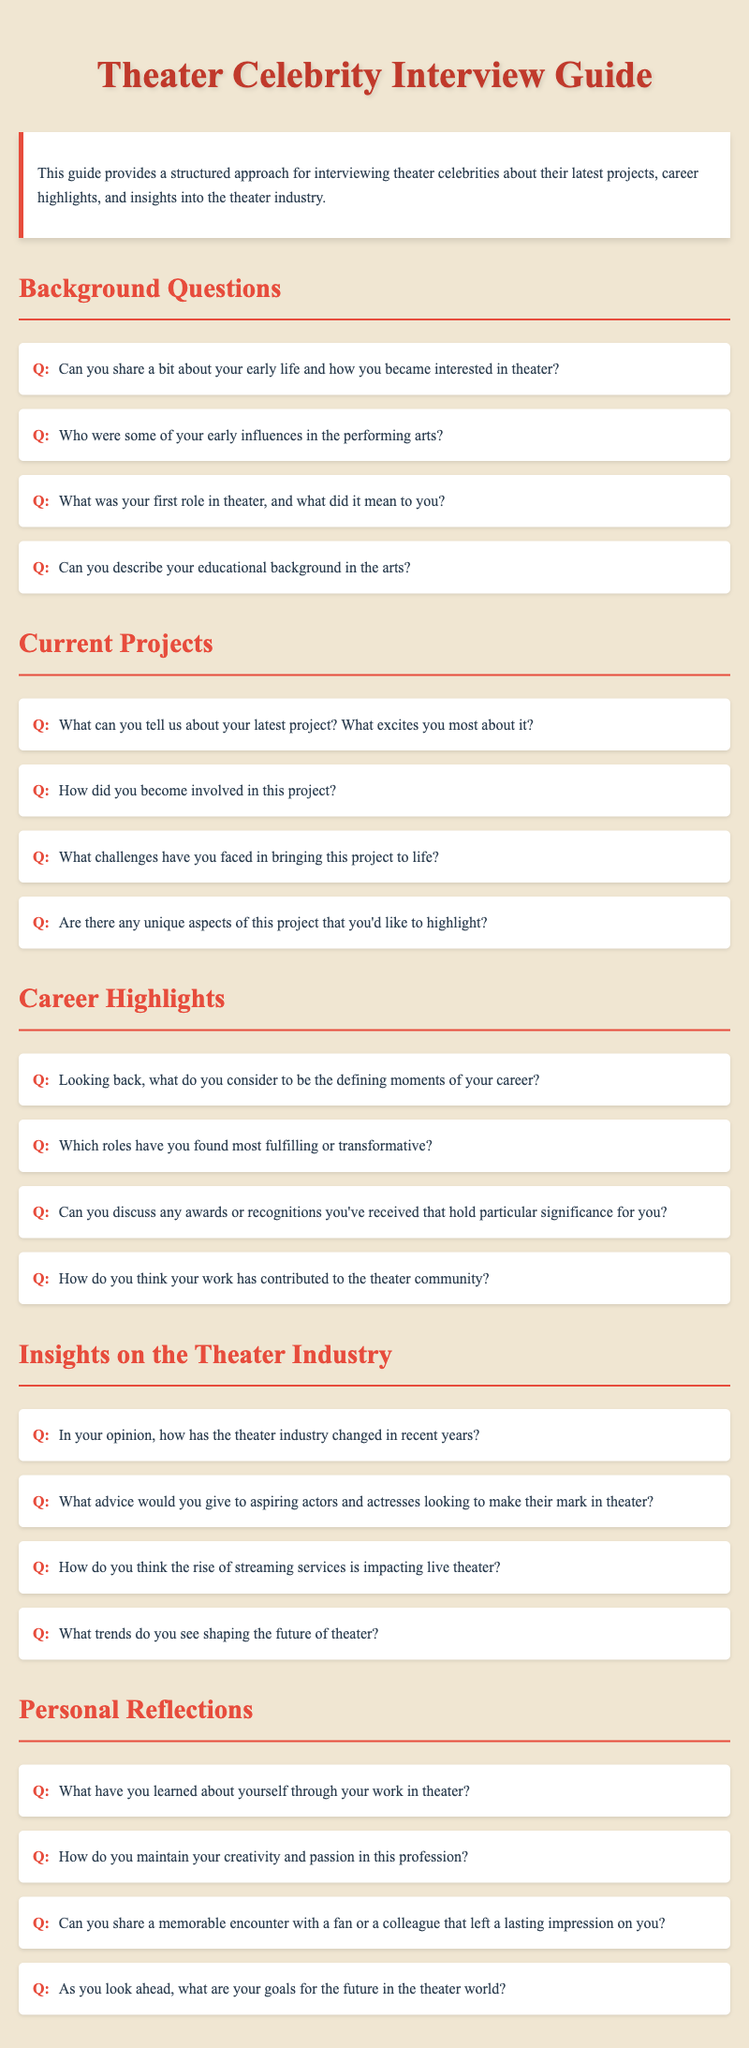What is the title of the document? The title is displayed prominently at the top of the document as the main header.
Answer: Theater Celebrity Interview Guide How many sections are in the document? The sections can be counted from the headings provided in the document.
Answer: 5 What does the introduction highlight? The introduction summarizes the purpose of the guide.
Answer: A structured approach for interviewing theater celebrities What type of questions are included in the "Current Projects" section? This section consists of questions focused on the celebrity's latest works.
Answer: Questions about their latest project Which question addresses career highlights? This question specifically looks for significant moments in a celebrity's career.
Answer: Looking back, what do you consider to be the defining moments of your career? What do the "Personal Reflections" questions aim to uncover? This section seeks to explore the individual's thoughts and feelings gained from their experiences.
Answer: Insights about themselves through theater work 